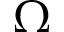<formula> <loc_0><loc_0><loc_500><loc_500>\Omega</formula> 